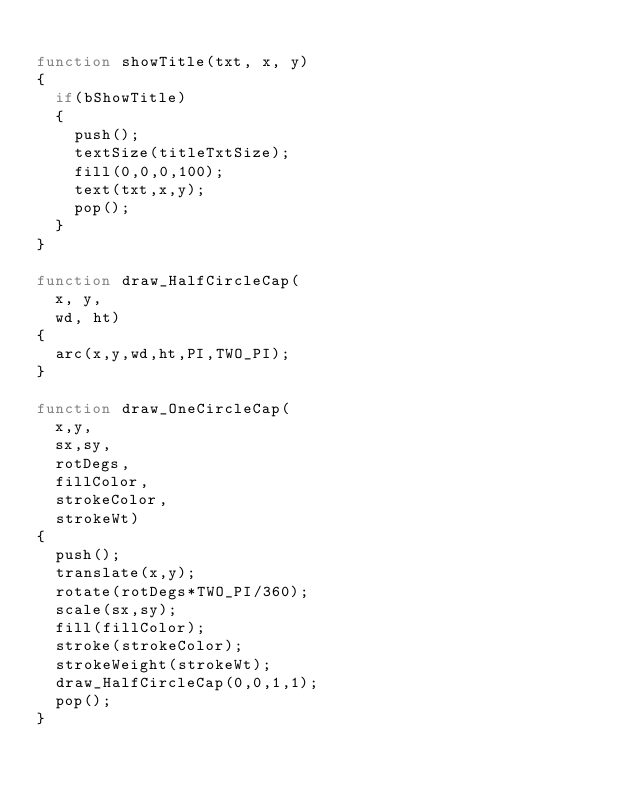<code> <loc_0><loc_0><loc_500><loc_500><_JavaScript_>
function showTitle(txt, x, y)
{
  if(bShowTitle)
  {
    push();
    textSize(titleTxtSize);
    fill(0,0,0,100);
    text(txt,x,y);
    pop();
  }
}

function draw_HalfCircleCap(
  x, y,
  wd, ht)
{
  arc(x,y,wd,ht,PI,TWO_PI);
}

function draw_OneCircleCap(
  x,y, 
  sx,sy,
  rotDegs,
  fillColor,
  strokeColor,
  strokeWt)
{
  push();
  translate(x,y);
  rotate(rotDegs*TWO_PI/360);
  scale(sx,sy);
  fill(fillColor);
  stroke(strokeColor);
  strokeWeight(strokeWt);
  draw_HalfCircleCap(0,0,1,1);
  pop();
}</code> 